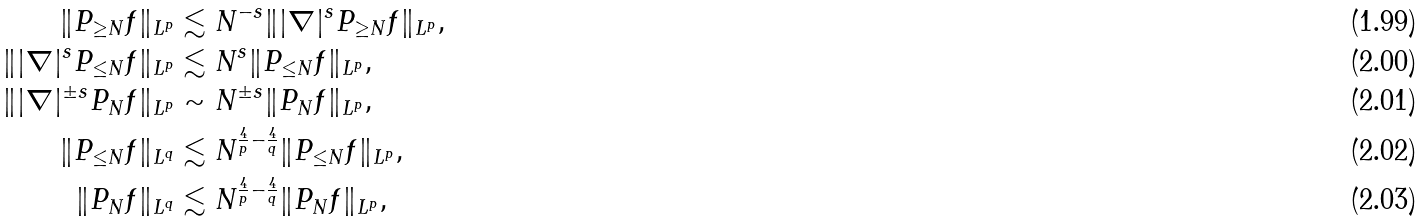Convert formula to latex. <formula><loc_0><loc_0><loc_500><loc_500>\| P _ { \geq N } f \| _ { L ^ { p } } & \lesssim N ^ { - s } \| | \nabla | ^ { s } P _ { \geq N } f \| _ { L ^ { p } } , \\ \| | \nabla | ^ { s } P _ { \leq N } f \| _ { L ^ { p } } & \lesssim N ^ { s } \| P _ { \leq N } f \| _ { L ^ { p } } , \\ \| | \nabla | ^ { \pm s } P _ { N } f \| _ { L ^ { p } } & \sim N ^ { \pm s } \| P _ { N } f \| _ { L ^ { p } } , \\ \| P _ { \leq N } f \| _ { L ^ { q } } & \lesssim N ^ { \frac { 4 } { p } - \frac { 4 } { q } } \| P _ { \leq N } f \| _ { L ^ { p } } , \\ \| P _ { N } f \| _ { L ^ { q } } & \lesssim N ^ { \frac { 4 } { p } - \frac { 4 } { q } } \| P _ { N } f \| _ { L ^ { p } } ,</formula> 